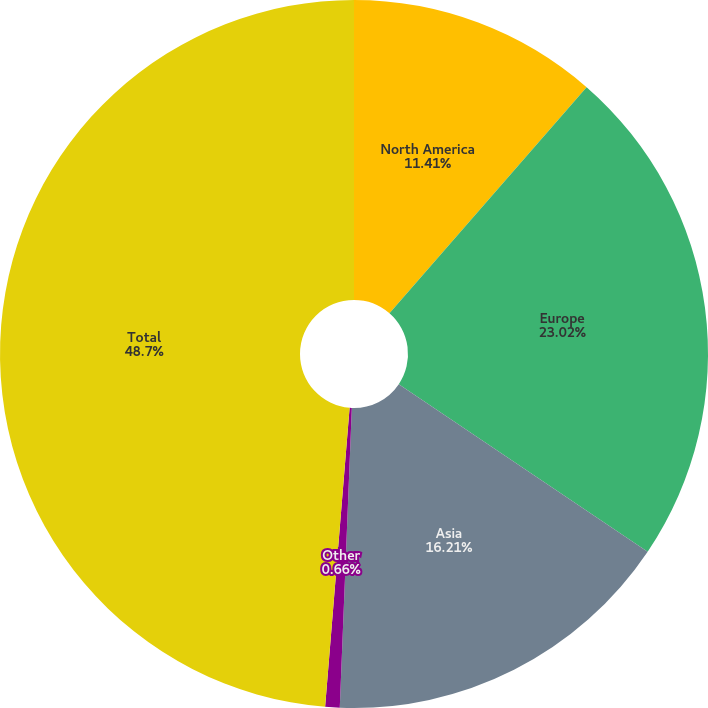<chart> <loc_0><loc_0><loc_500><loc_500><pie_chart><fcel>North America<fcel>Europe<fcel>Asia<fcel>Other<fcel>Total<nl><fcel>11.41%<fcel>23.02%<fcel>16.21%<fcel>0.66%<fcel>48.7%<nl></chart> 